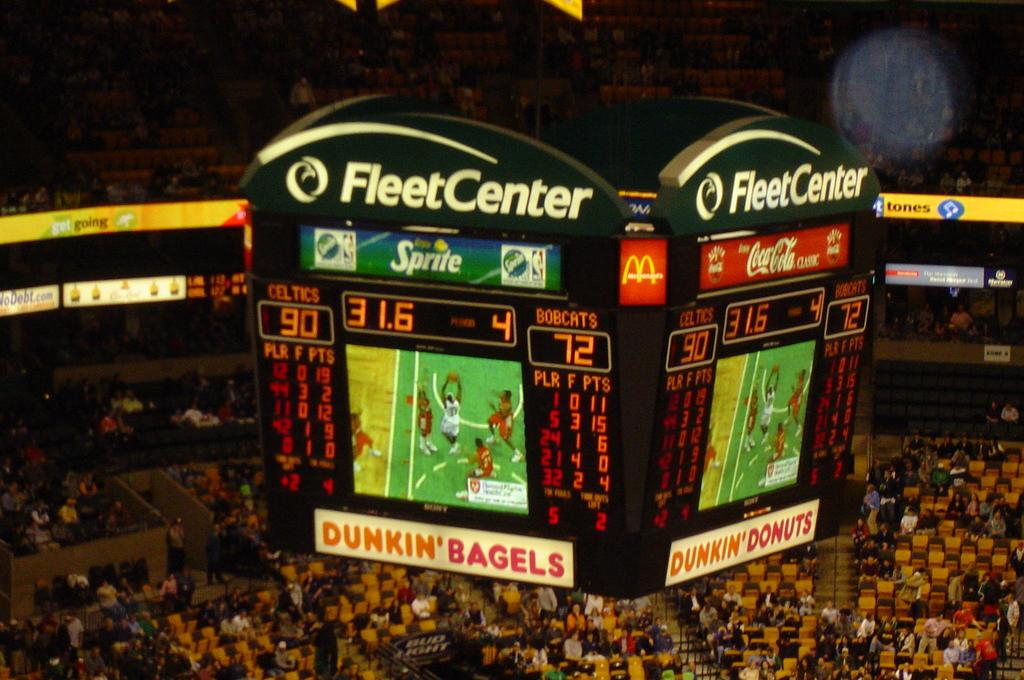<image>
Describe the image concisely. A crowd is gathered in the Fleet Center, the scoreboard hanging in the arena shows the score of the basketball game and images of the action below. 